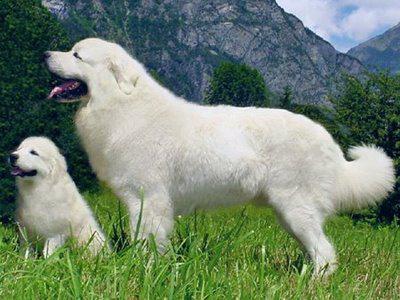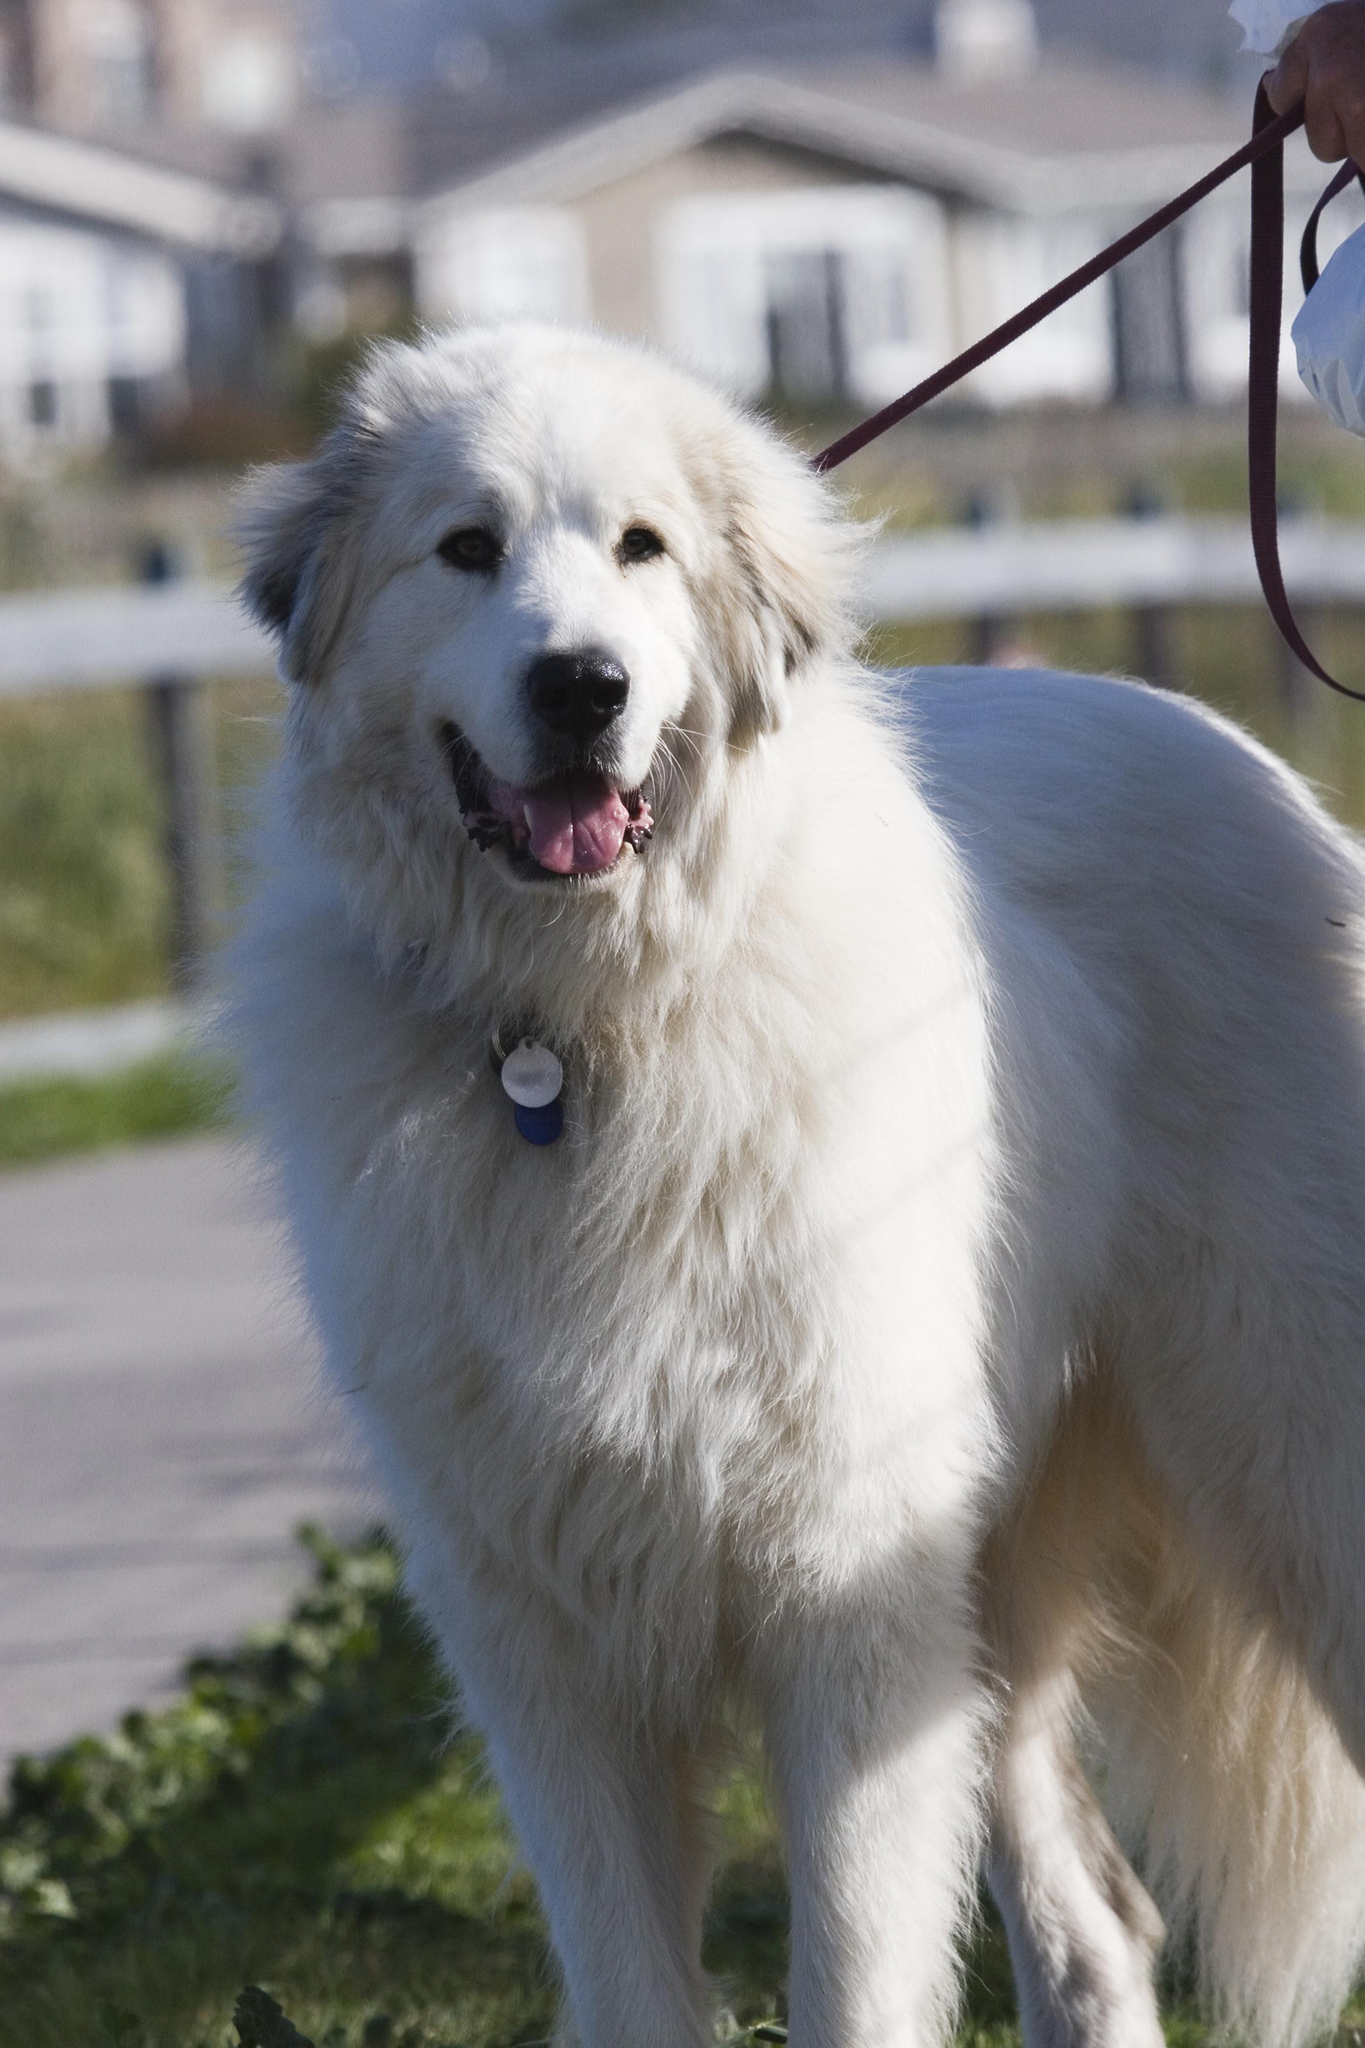The first image is the image on the left, the second image is the image on the right. Considering the images on both sides, is "The image on the left contains only the dog's head and chest." valid? Answer yes or no. No. 